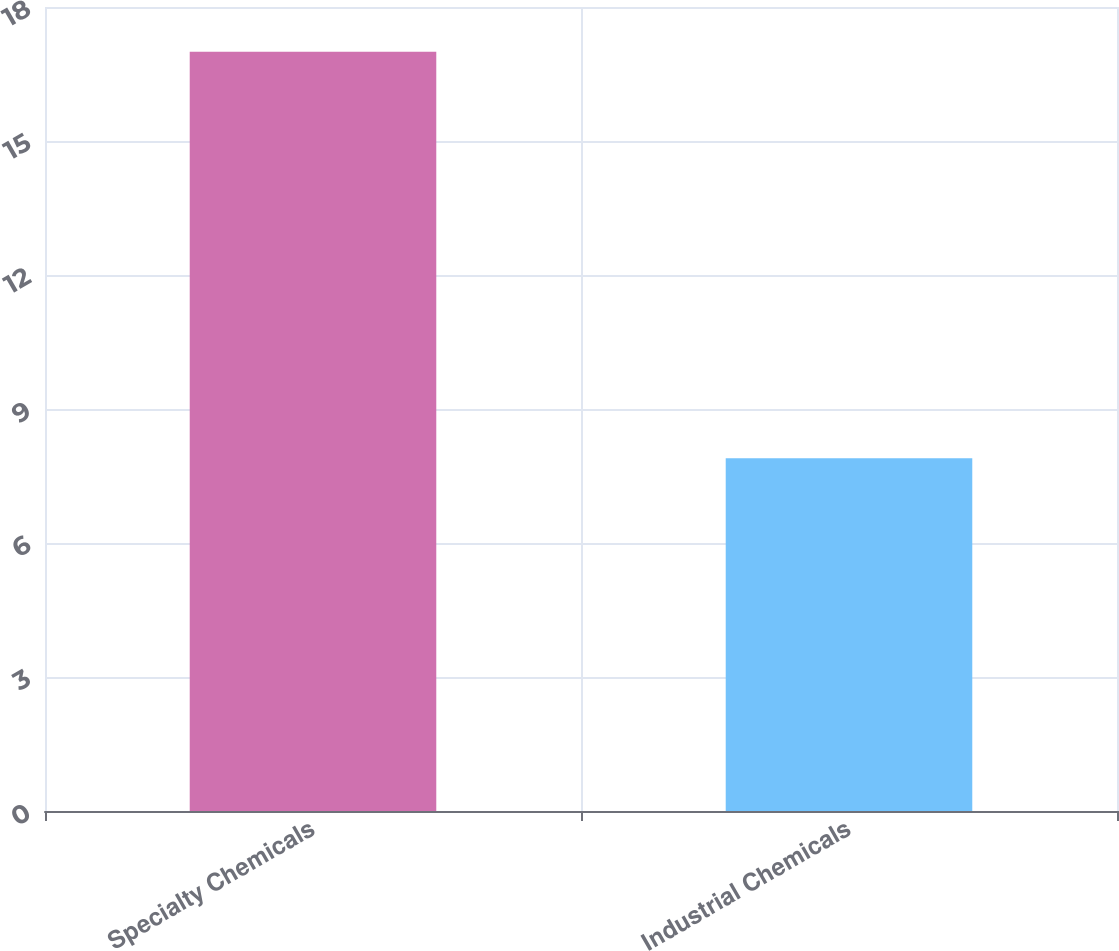Convert chart to OTSL. <chart><loc_0><loc_0><loc_500><loc_500><bar_chart><fcel>Specialty Chemicals<fcel>Industrial Chemicals<nl><fcel>17<fcel>7.9<nl></chart> 